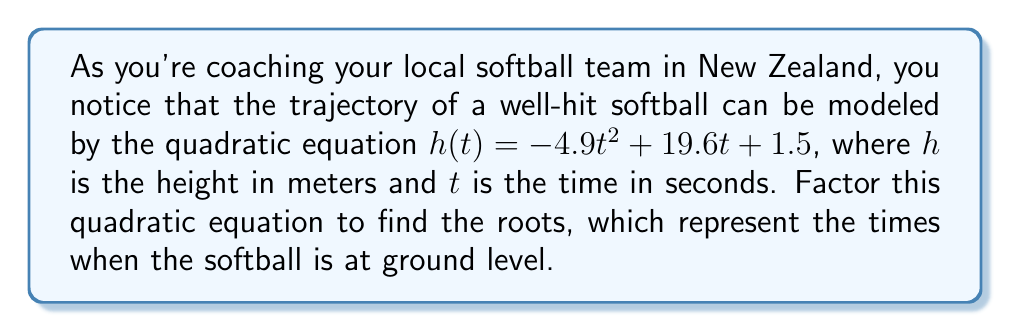Provide a solution to this math problem. To factor this quadratic equation, we'll follow these steps:

1) First, identify the coefficients:
   $a = -4.9$, $b = 19.6$, and $c = 1.5$

2) Use the quadratic formula: $t = \frac{-b \pm \sqrt{b^2 - 4ac}}{2a}$

3) Substitute the values:
   $$t = \frac{-19.6 \pm \sqrt{19.6^2 - 4(-4.9)(1.5)}}{2(-4.9)}$$

4) Simplify under the square root:
   $$t = \frac{-19.6 \pm \sqrt{384.16 + 29.4}}{-9.8}$$
   $$t = \frac{-19.6 \pm \sqrt{413.56}}{-9.8}$$
   $$t = \frac{-19.6 \pm 20.34}{-9.8}$$

5) Solve for the two roots:
   $$t_1 = \frac{-19.6 + 20.34}{-9.8} = \frac{0.74}{-9.8} = -0.08$$
   $$t_2 = \frac{-19.6 - 20.34}{-9.8} = \frac{-39.94}{-9.8} = 4.08$$

6) The factored form of the quadratic equation is:
   $$h(t) = -4.9(t + 0.08)(t - 4.08)$$

This factors the original equation and gives us the roots, which represent the times when the softball is at ground level (height = 0).
Answer: $h(t) = -4.9(t + 0.08)(t - 4.08)$ 